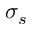Convert formula to latex. <formula><loc_0><loc_0><loc_500><loc_500>\sigma _ { s }</formula> 